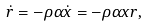Convert formula to latex. <formula><loc_0><loc_0><loc_500><loc_500>\dot { r } = - \rho \alpha \dot { x } = - \rho \alpha x r ,</formula> 